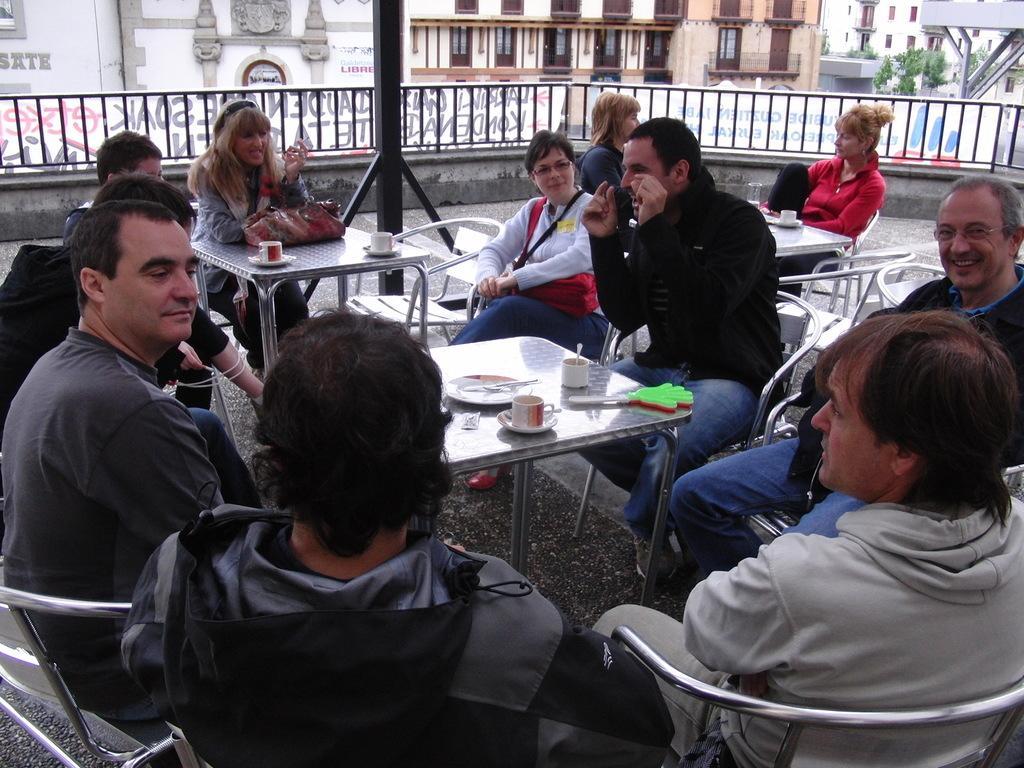Describe this image in one or two sentences. In the image we can see there are lot of people who are sitting on chair and on table there is cup with soccer and there is spoon, knife and a purse of a woman and behind there are buildings. 